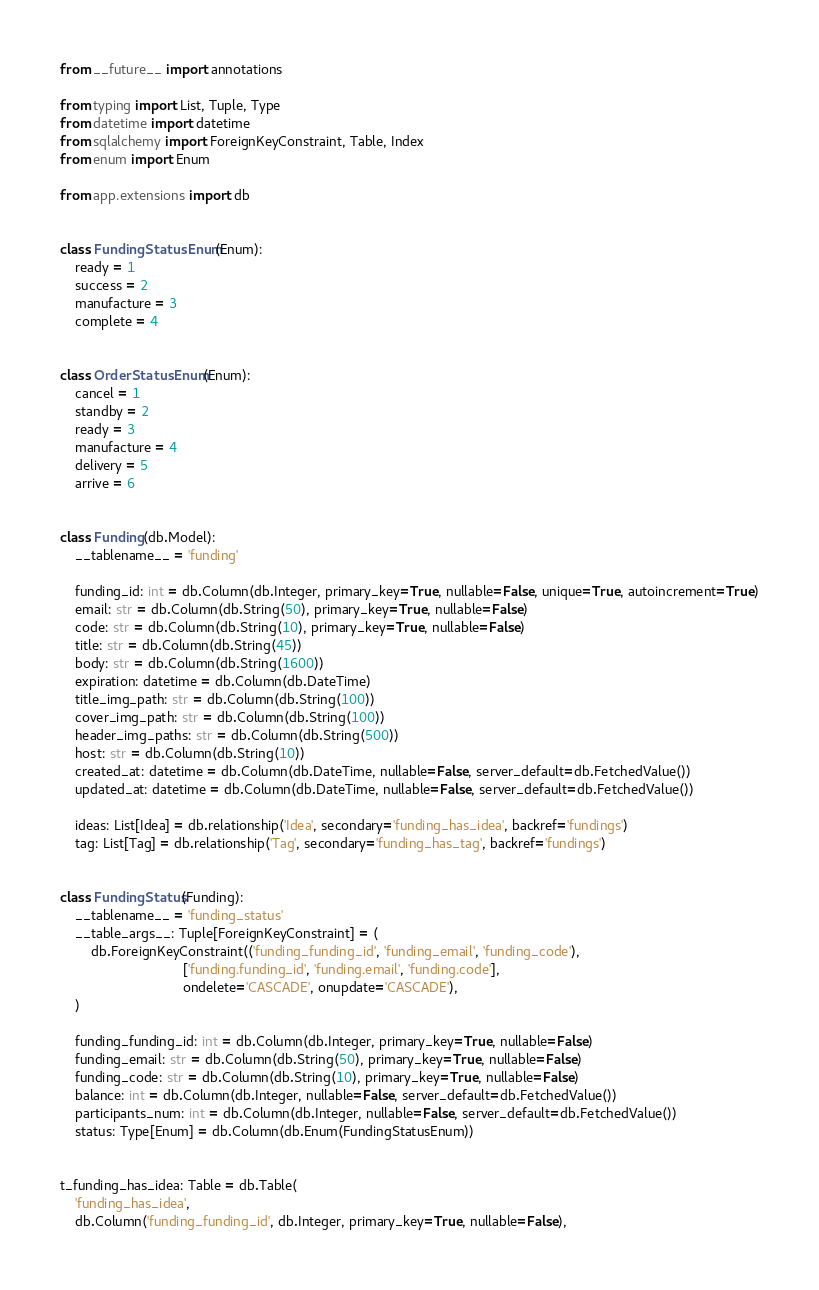<code> <loc_0><loc_0><loc_500><loc_500><_Python_>from __future__ import annotations

from typing import List, Tuple, Type
from datetime import datetime
from sqlalchemy import ForeignKeyConstraint, Table, Index
from enum import Enum

from app.extensions import db


class FundingStatusEnum(Enum):
    ready = 1
    success = 2
    manufacture = 3
    complete = 4


class OrderStatusEnum(Enum):
    cancel = 1
    standby = 2
    ready = 3
    manufacture = 4
    delivery = 5
    arrive = 6


class Funding(db.Model):
    __tablename__ = 'funding'

    funding_id: int = db.Column(db.Integer, primary_key=True, nullable=False, unique=True, autoincrement=True)
    email: str = db.Column(db.String(50), primary_key=True, nullable=False)
    code: str = db.Column(db.String(10), primary_key=True, nullable=False)
    title: str = db.Column(db.String(45))
    body: str = db.Column(db.String(1600))
    expiration: datetime = db.Column(db.DateTime)
    title_img_path: str = db.Column(db.String(100))
    cover_img_path: str = db.Column(db.String(100))
    header_img_paths: str = db.Column(db.String(500))
    host: str = db.Column(db.String(10))
    created_at: datetime = db.Column(db.DateTime, nullable=False, server_default=db.FetchedValue())
    updated_at: datetime = db.Column(db.DateTime, nullable=False, server_default=db.FetchedValue())

    ideas: List[Idea] = db.relationship('Idea', secondary='funding_has_idea', backref='fundings')
    tag: List[Tag] = db.relationship('Tag', secondary='funding_has_tag', backref='fundings')


class FundingStatus(Funding):
    __tablename__ = 'funding_status'
    __table_args__: Tuple[ForeignKeyConstraint] = (
        db.ForeignKeyConstraint(('funding_funding_id', 'funding_email', 'funding_code'),
                                ['funding.funding_id', 'funding.email', 'funding.code'],
                                ondelete='CASCADE', onupdate='CASCADE'),
    )

    funding_funding_id: int = db.Column(db.Integer, primary_key=True, nullable=False)
    funding_email: str = db.Column(db.String(50), primary_key=True, nullable=False)
    funding_code: str = db.Column(db.String(10), primary_key=True, nullable=False)
    balance: int = db.Column(db.Integer, nullable=False, server_default=db.FetchedValue())
    participants_num: int = db.Column(db.Integer, nullable=False, server_default=db.FetchedValue())
    status: Type[Enum] = db.Column(db.Enum(FundingStatusEnum))


t_funding_has_idea: Table = db.Table(
    'funding_has_idea',
    db.Column('funding_funding_id', db.Integer, primary_key=True, nullable=False),</code> 